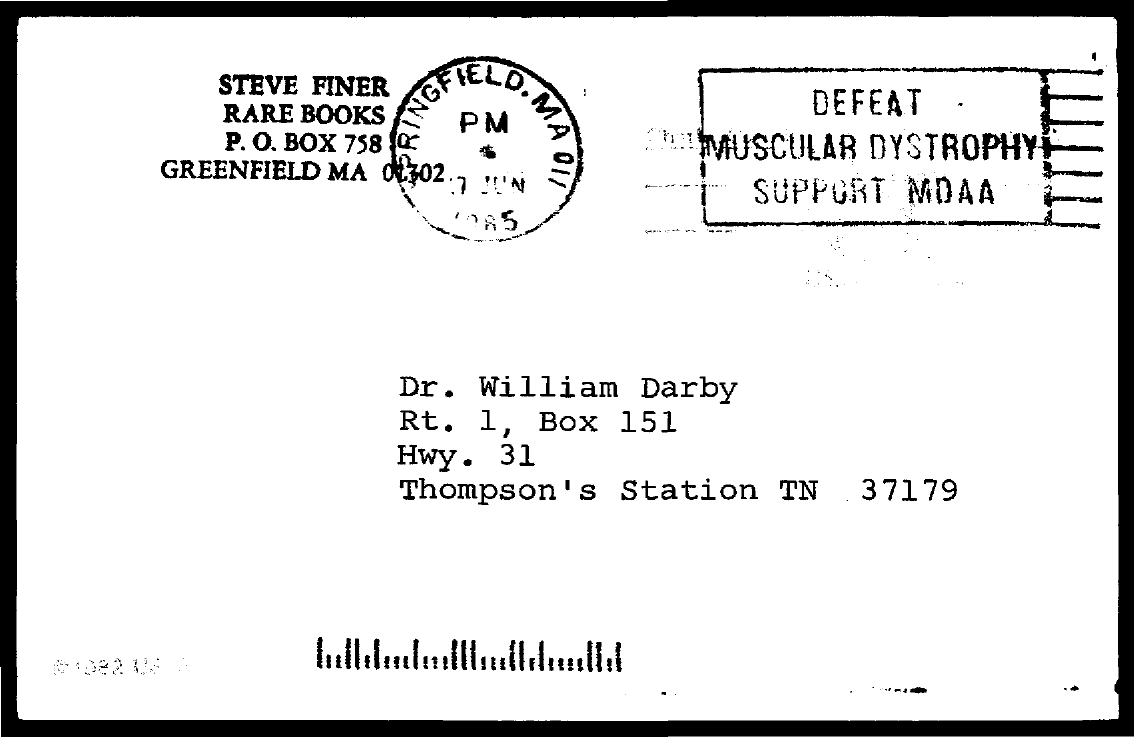Indicate a few pertinent items in this graphic. The PO Box number of Steve Finer Rare Books is 758. 